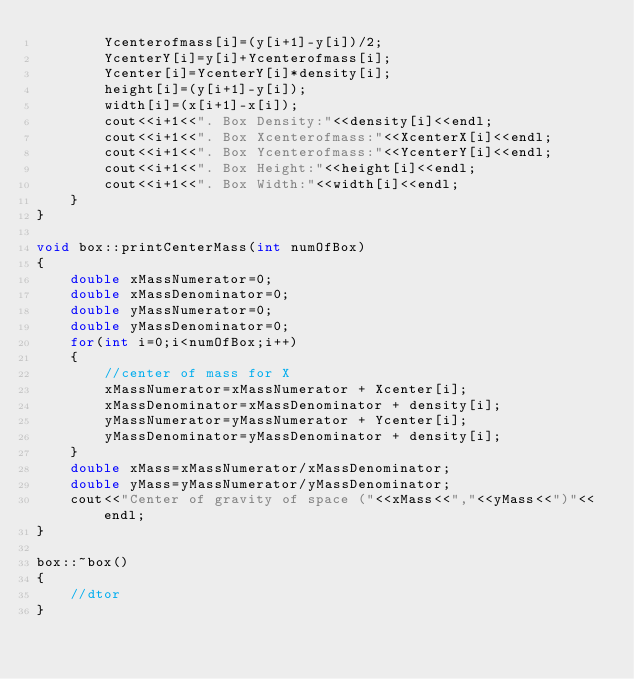Convert code to text. <code><loc_0><loc_0><loc_500><loc_500><_C++_>        Ycenterofmass[i]=(y[i+1]-y[i])/2;
        YcenterY[i]=y[i]+Ycenterofmass[i];
        Ycenter[i]=YcenterY[i]*density[i];
        height[i]=(y[i+1]-y[i]);
        width[i]=(x[i+1]-x[i]);
        cout<<i+1<<". Box Density:"<<density[i]<<endl;
        cout<<i+1<<". Box Xcenterofmass:"<<XcenterX[i]<<endl;
        cout<<i+1<<". Box Ycenterofmass:"<<YcenterY[i]<<endl;
        cout<<i+1<<". Box Height:"<<height[i]<<endl;
        cout<<i+1<<". Box Width:"<<width[i]<<endl;
    }
}

void box::printCenterMass(int numOfBox)
{
    double xMassNumerator=0;
    double xMassDenominator=0;
    double yMassNumerator=0;
    double yMassDenominator=0;
    for(int i=0;i<numOfBox;i++)
    {
        //center of mass for X
        xMassNumerator=xMassNumerator + Xcenter[i];
        xMassDenominator=xMassDenominator + density[i];
        yMassNumerator=yMassNumerator + Ycenter[i];
        yMassDenominator=yMassDenominator + density[i];
    }
    double xMass=xMassNumerator/xMassDenominator;
    double yMass=yMassNumerator/yMassDenominator;
    cout<<"Center of gravity of space ("<<xMass<<","<<yMass<<")"<<endl;
}

box::~box()
{
    //dtor
}
</code> 